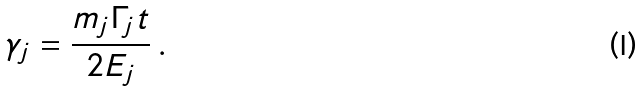<formula> <loc_0><loc_0><loc_500><loc_500>\gamma _ { j } = \frac { m _ { j } \Gamma _ { j } t } { 2 E _ { j } } \, .</formula> 